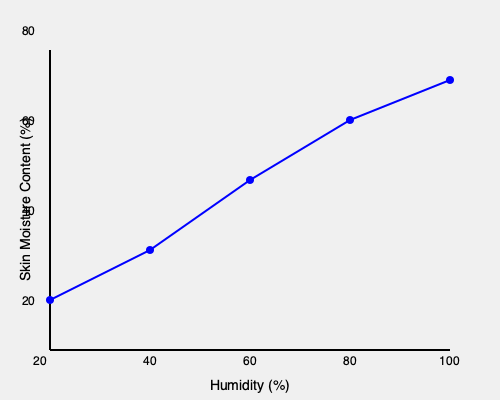Based on the graph showing the relationship between humidity and skin moisture content in amphibians, calculate the rate of change in skin moisture content per 1% increase in humidity between 40% and 80% humidity levels. Express your answer as a percentage with two decimal places. To calculate the rate of change in skin moisture content per 1% increase in humidity between 40% and 80% humidity levels, we'll follow these steps:

1. Identify the skin moisture content at 40% and 80% humidity:
   At 40% humidity: 45% skin moisture content
   At 80% humidity: 65% skin moisture content

2. Calculate the total change in skin moisture content:
   $\Delta\text{Moisture} = 65\% - 45\% = 20\%$

3. Calculate the total change in humidity:
   $\Delta\text{Humidity} = 80\% - 40\% = 40\%$

4. Calculate the rate of change per 1% increase in humidity:
   $\text{Rate of change} = \frac{\Delta\text{Moisture}}{\Delta\text{Humidity}}$
   $= \frac{20\%}{40\%} = 0.5\%$

5. Express the answer as a percentage with two decimal places:
   $0.5\% = 0.50\%$

Therefore, the rate of change in skin moisture content is 0.50% per 1% increase in humidity between 40% and 80% humidity levels.
Answer: 0.50% 